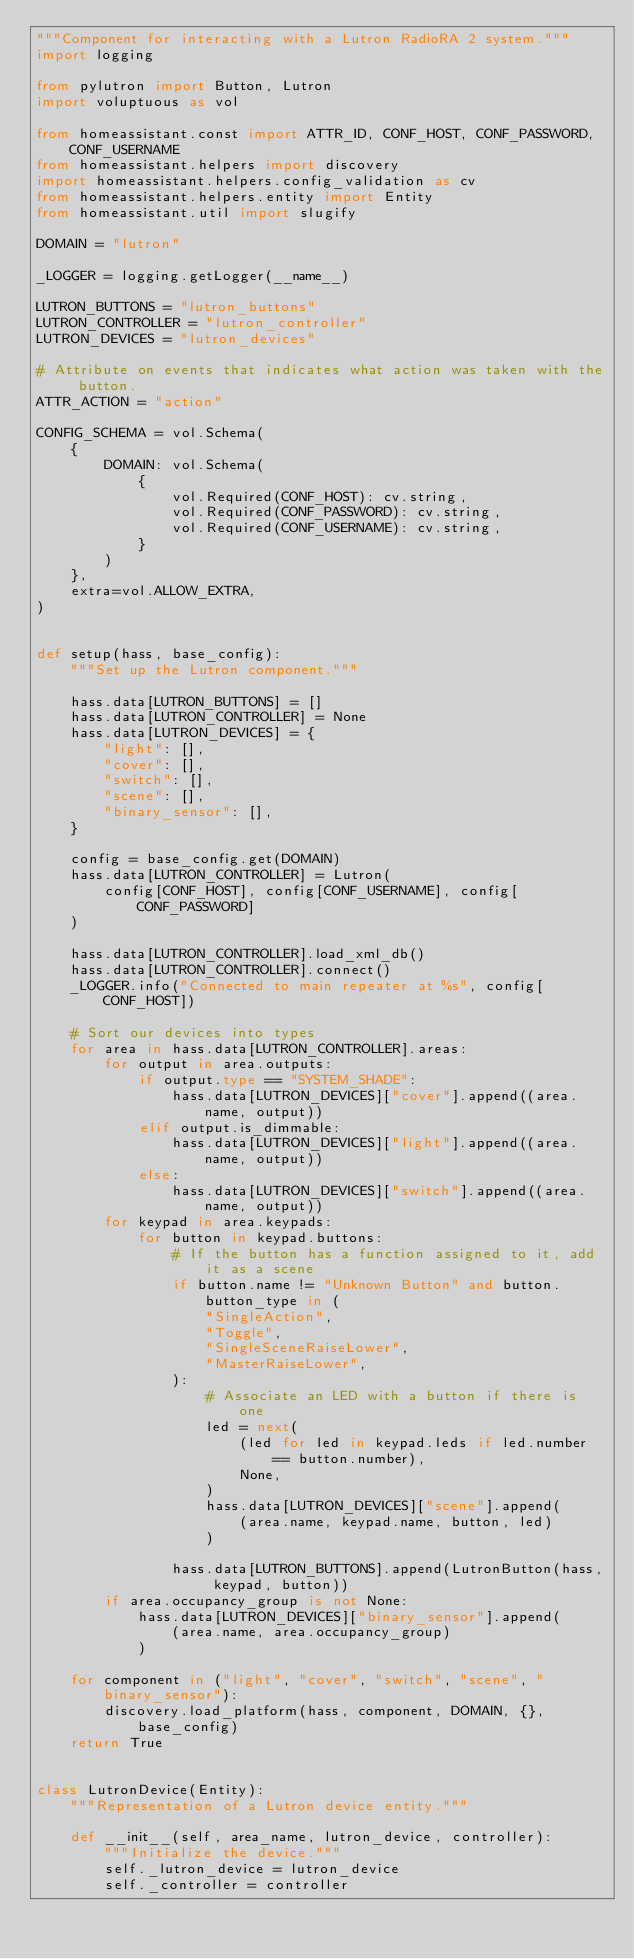<code> <loc_0><loc_0><loc_500><loc_500><_Python_>"""Component for interacting with a Lutron RadioRA 2 system."""
import logging

from pylutron import Button, Lutron
import voluptuous as vol

from homeassistant.const import ATTR_ID, CONF_HOST, CONF_PASSWORD, CONF_USERNAME
from homeassistant.helpers import discovery
import homeassistant.helpers.config_validation as cv
from homeassistant.helpers.entity import Entity
from homeassistant.util import slugify

DOMAIN = "lutron"

_LOGGER = logging.getLogger(__name__)

LUTRON_BUTTONS = "lutron_buttons"
LUTRON_CONTROLLER = "lutron_controller"
LUTRON_DEVICES = "lutron_devices"

# Attribute on events that indicates what action was taken with the button.
ATTR_ACTION = "action"

CONFIG_SCHEMA = vol.Schema(
    {
        DOMAIN: vol.Schema(
            {
                vol.Required(CONF_HOST): cv.string,
                vol.Required(CONF_PASSWORD): cv.string,
                vol.Required(CONF_USERNAME): cv.string,
            }
        )
    },
    extra=vol.ALLOW_EXTRA,
)


def setup(hass, base_config):
    """Set up the Lutron component."""

    hass.data[LUTRON_BUTTONS] = []
    hass.data[LUTRON_CONTROLLER] = None
    hass.data[LUTRON_DEVICES] = {
        "light": [],
        "cover": [],
        "switch": [],
        "scene": [],
        "binary_sensor": [],
    }

    config = base_config.get(DOMAIN)
    hass.data[LUTRON_CONTROLLER] = Lutron(
        config[CONF_HOST], config[CONF_USERNAME], config[CONF_PASSWORD]
    )

    hass.data[LUTRON_CONTROLLER].load_xml_db()
    hass.data[LUTRON_CONTROLLER].connect()
    _LOGGER.info("Connected to main repeater at %s", config[CONF_HOST])

    # Sort our devices into types
    for area in hass.data[LUTRON_CONTROLLER].areas:
        for output in area.outputs:
            if output.type == "SYSTEM_SHADE":
                hass.data[LUTRON_DEVICES]["cover"].append((area.name, output))
            elif output.is_dimmable:
                hass.data[LUTRON_DEVICES]["light"].append((area.name, output))
            else:
                hass.data[LUTRON_DEVICES]["switch"].append((area.name, output))
        for keypad in area.keypads:
            for button in keypad.buttons:
                # If the button has a function assigned to it, add it as a scene
                if button.name != "Unknown Button" and button.button_type in (
                    "SingleAction",
                    "Toggle",
                    "SingleSceneRaiseLower",
                    "MasterRaiseLower",
                ):
                    # Associate an LED with a button if there is one
                    led = next(
                        (led for led in keypad.leds if led.number == button.number),
                        None,
                    )
                    hass.data[LUTRON_DEVICES]["scene"].append(
                        (area.name, keypad.name, button, led)
                    )

                hass.data[LUTRON_BUTTONS].append(LutronButton(hass, keypad, button))
        if area.occupancy_group is not None:
            hass.data[LUTRON_DEVICES]["binary_sensor"].append(
                (area.name, area.occupancy_group)
            )

    for component in ("light", "cover", "switch", "scene", "binary_sensor"):
        discovery.load_platform(hass, component, DOMAIN, {}, base_config)
    return True


class LutronDevice(Entity):
    """Representation of a Lutron device entity."""

    def __init__(self, area_name, lutron_device, controller):
        """Initialize the device."""
        self._lutron_device = lutron_device
        self._controller = controller</code> 